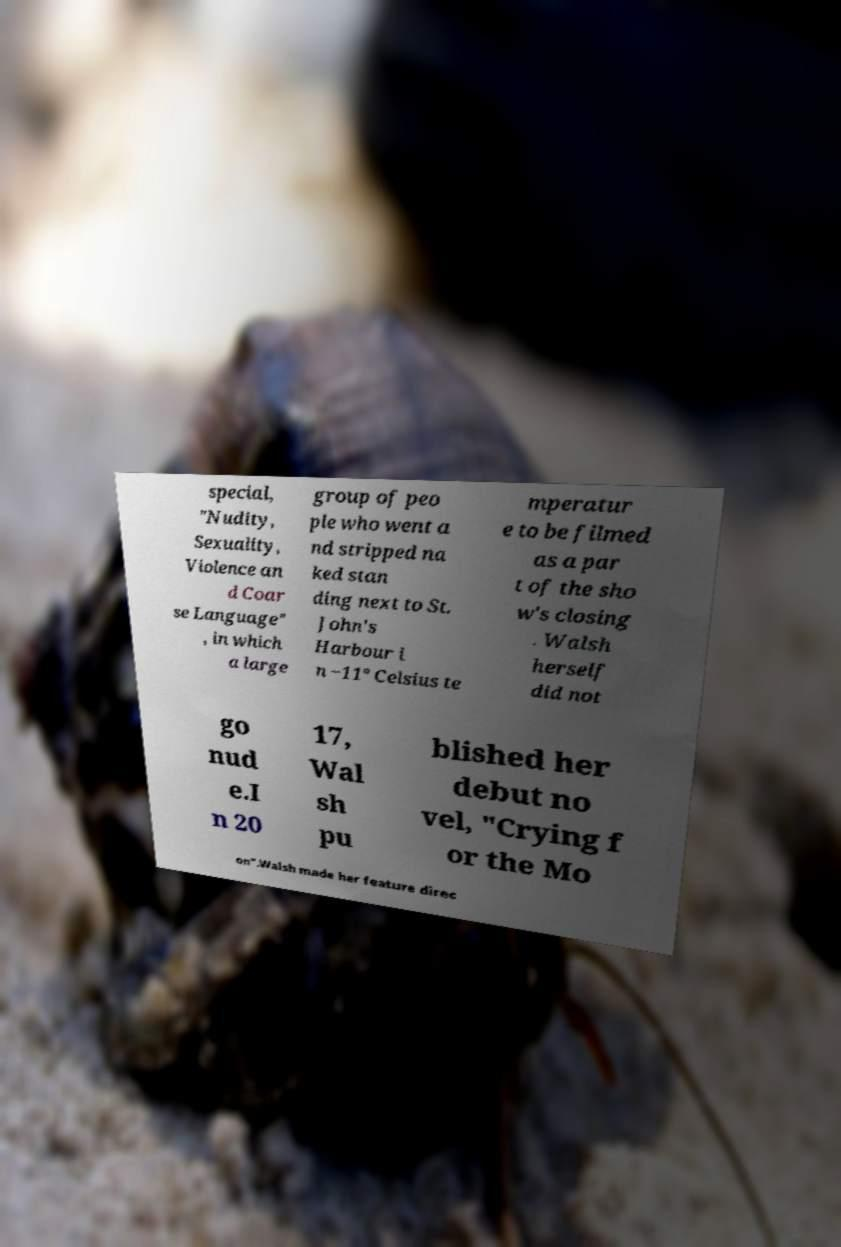Can you read and provide the text displayed in the image?This photo seems to have some interesting text. Can you extract and type it out for me? special, "Nudity, Sexuality, Violence an d Coar se Language" , in which a large group of peo ple who went a nd stripped na ked stan ding next to St. John's Harbour i n −11° Celsius te mperatur e to be filmed as a par t of the sho w's closing . Walsh herself did not go nud e.I n 20 17, Wal sh pu blished her debut no vel, "Crying f or the Mo on".Walsh made her feature direc 